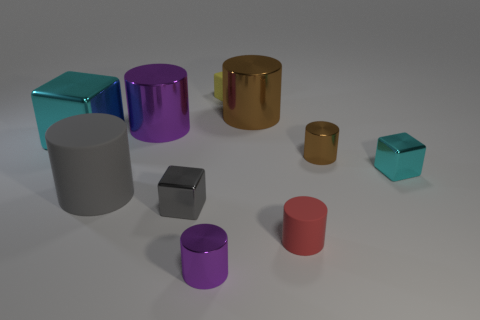Subtract 2 cylinders. How many cylinders are left? 4 Subtract all brown cylinders. How many cylinders are left? 4 Subtract all brown cylinders. How many cylinders are left? 4 Subtract all blue cylinders. Subtract all purple spheres. How many cylinders are left? 6 Subtract all blocks. How many objects are left? 6 Subtract 0 purple balls. How many objects are left? 10 Subtract all large gray matte objects. Subtract all gray blocks. How many objects are left? 8 Add 1 rubber cylinders. How many rubber cylinders are left? 3 Add 7 tiny purple cylinders. How many tiny purple cylinders exist? 8 